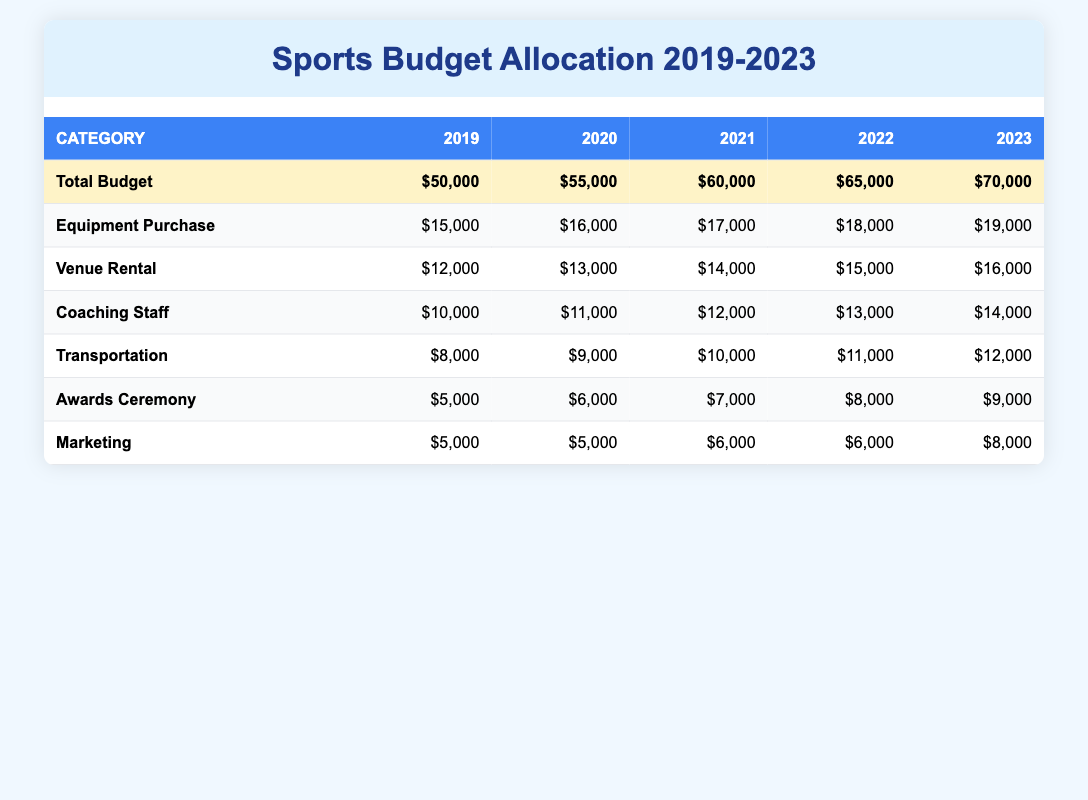What was the total budget for the sports programs in 2021? The total budget for 2021 is listed in the "Total Budget" row for that year, which shows $60,000.
Answer: $60,000 Which year had the highest allocation for equipment purchase? By looking at the "Equipment Purchase" row, the values for each year are compared: 2019 ($15,000), 2020 ($16,000), 2021 ($17,000), 2022 ($18,000), and 2023 ($19,000). The highest value is $19,000 in 2023.
Answer: 2023 What is the difference in budget allocation for transportation between 2019 and 2023? The transportation allocation for 2019 is $8,000 and for 2023 is $12,000. The difference is $12,000 - $8,000 = $4,000.
Answer: $4,000 Did the marketing budget increase every year from 2019 to 2023? The marketing allocations are: 2019 ($5,000), 2020 ($5,000), 2021 ($6,000), 2022 ($6,000), and 2023 ($8,000). The marketing budget was constant in 2019 and 2020, so it did not increase every year.
Answer: No What was the total budget for all five years combined? To find the total of the budgets from 2019 to 2023, sum up all total budgets: $50,000 + $55,000 + $60,000 + $65,000 + $70,000 = $300,000.
Answer: $300,000 If we consider the awards ceremony budget over the five years, what is the average amount allocated per year? The awards ceremony allocations are: 2019 ($5,000), 2020 ($6,000), 2021 ($7,000), 2022 ($8,000), and 2023 ($9,000). The sum is $5,000 + $6,000 + $7,000 + $8,000 + $9,000 = $35,000. The average is $35,000 divided by 5, which equals $7,000.
Answer: $7,000 What was the percent increase in total budget from 2019 to 2023? The total budget increased from $50,000 in 2019 to $70,000 in 2023. The increase is $70,000 - $50,000 = $20,000. The percent increase is ($20,000 / $50,000) * 100 = 40%.
Answer: 40% Which year had the lowest expense on coaching staff, and what was that amount? The coaching staff allocations are: 2019 ($10,000), 2020 ($11,000), 2021 ($12,000), 2022 ($13,000), and 2023 ($14,000). The lowest allocation is $10,000 in 2019.
Answer: 2019, $10,000 How much more was spent on venue rental in 2022 compared to 2021? The venue rental for 2022 is $15,000 and for 2021 is $14,000. The difference is $15,000 - $14,000 = $1,000.
Answer: $1,000 What is the total amount allocated for awards ceremony across all years? The total allocations for the awards ceremony are: $5,000 (2019) + $6,000 (2020) + $7,000 (2021) + $8,000 (2022) + $9,000 (2023) = $35,000.
Answer: $35,000 